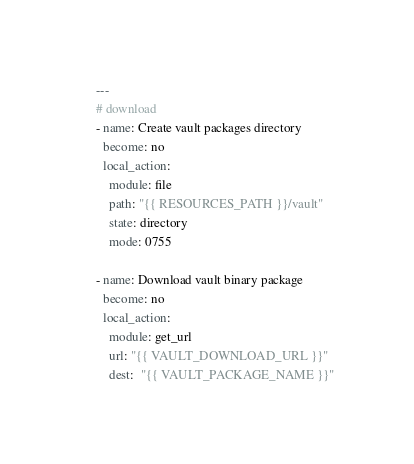Convert code to text. <code><loc_0><loc_0><loc_500><loc_500><_YAML_>---
# download
- name: Create vault packages directory
  become: no
  local_action:
    module: file
    path: "{{ RESOURCES_PATH }}/vault"
    state: directory
    mode: 0755

- name: Download vault binary package
  become: no
  local_action:
    module: get_url
    url: "{{ VAULT_DOWNLOAD_URL }}"
    dest:  "{{ VAULT_PACKAGE_NAME }}"</code> 